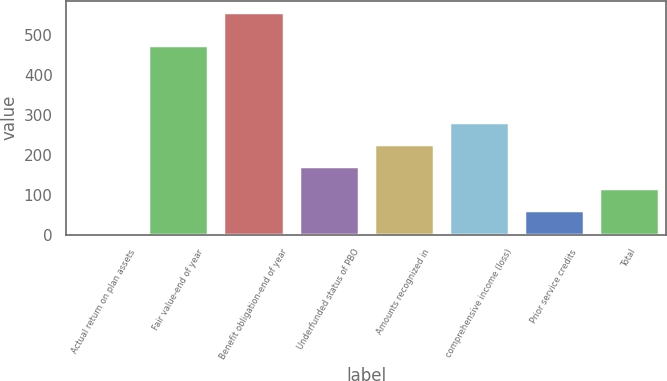Convert chart. <chart><loc_0><loc_0><loc_500><loc_500><bar_chart><fcel>Actual return on plan assets<fcel>Fair value-end of year<fcel>Benefit obligation-end of year<fcel>Underfunded status of PBO<fcel>Amounts recognized in<fcel>comprehensive income (loss)<fcel>Prior service credits<fcel>Total<nl><fcel>7<fcel>475<fcel>559<fcel>172.6<fcel>227.8<fcel>283<fcel>62.2<fcel>117.4<nl></chart> 